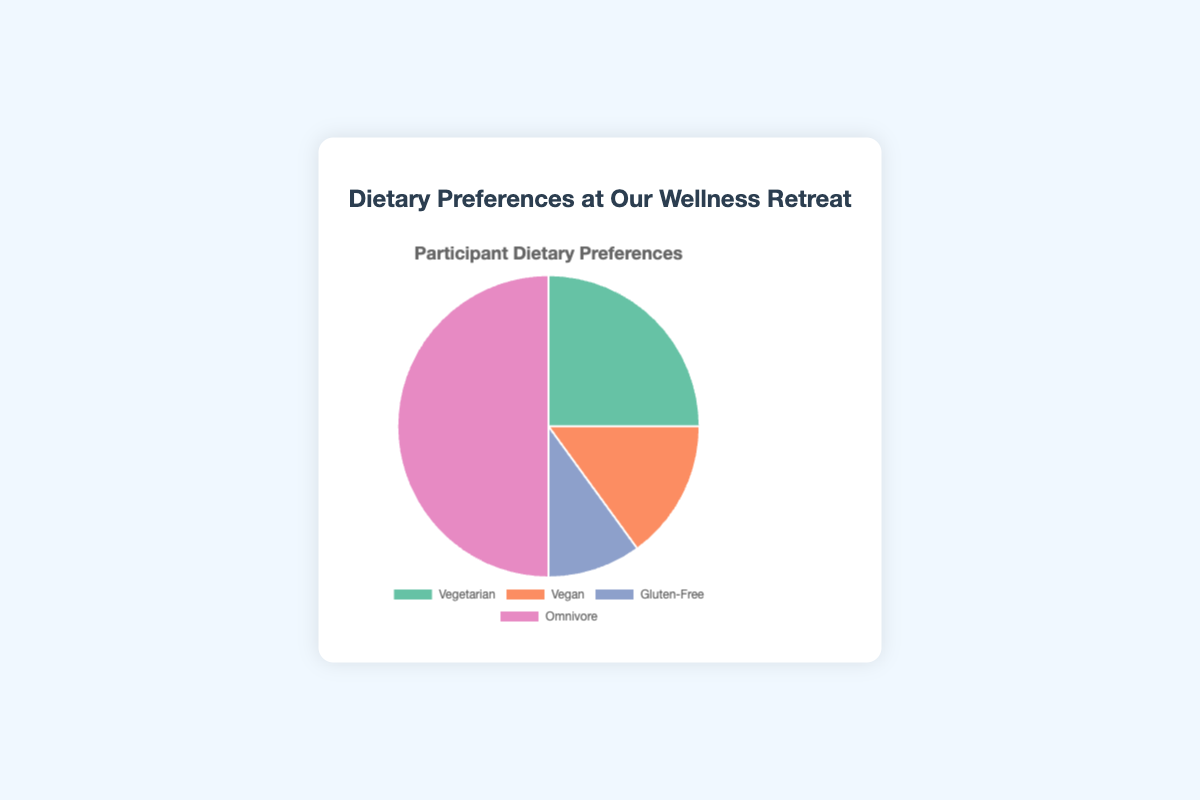What percentage of participants are neither Vegan nor Gluten-Free? First, find the total percentage of Vegan and Gluten-Free participants, which is 15% + 10% = 25%. Subtract this from 100% to find the percentage of participants who are neither Vegan nor Gluten-Free. Hence, 100% - 25% = 75%.
Answer: 75% How many dietary preference categories make up more than 20% of the participants? The categories are Vegetarian (25%), Vegan (15%), Gluten-Free (10%), and Omnivore (50%). Only Vegetarian (25%) and Omnivore (50%) are above 20%. So there are 2 categories.
Answer: 2 What is the combined percentage of participants who are either Vegan or Vegetarian? Add the percentage of Vegan participants (15%) to the percentage of Vegetarian participants (25%). Hence, 15% + 25% = 40%.
Answer: 40% Which dietary preference category has the smallest representation? Compare the percentages: Vegetarian (25%), Vegan (15%), Gluten-Free (10%), and Omnivore (50%). The smallest percentage is for Gluten-Free (10%).
Answer: Gluten-Free How does the percentage of Omnivores compare to the combined percentage of Vegetarians and Vegans? First, find the combined percentage of Vegetarians and Vegans: 25% + 15% = 40%. The percentage of Omnivores is 50%. Omnivores make up a higher percentage (50%) than the combined Vegetarians and Vegans (40%).
Answer: Higher What is the difference in percentage between the most and least represented dietary categories? The most represented category is Omnivore (50%) and the least is Gluten-Free (10%). The difference is 50% - 10% = 40%.
Answer: 40% What color represents the Vegetarian category in the pie chart? The pie chart uses the following colors: Vegetarian (green), Vegan (orange), Gluten-Free (blue), Omnivore (pink). The green color represents the Vegetarian category.
Answer: Green If the total number of participants is 200, how many are Gluten-Free? Given that 10% of participants are Gluten-Free, calculate 10% of 200 participants. This is (10/100) * 200 = 20 participants.
Answer: 20 